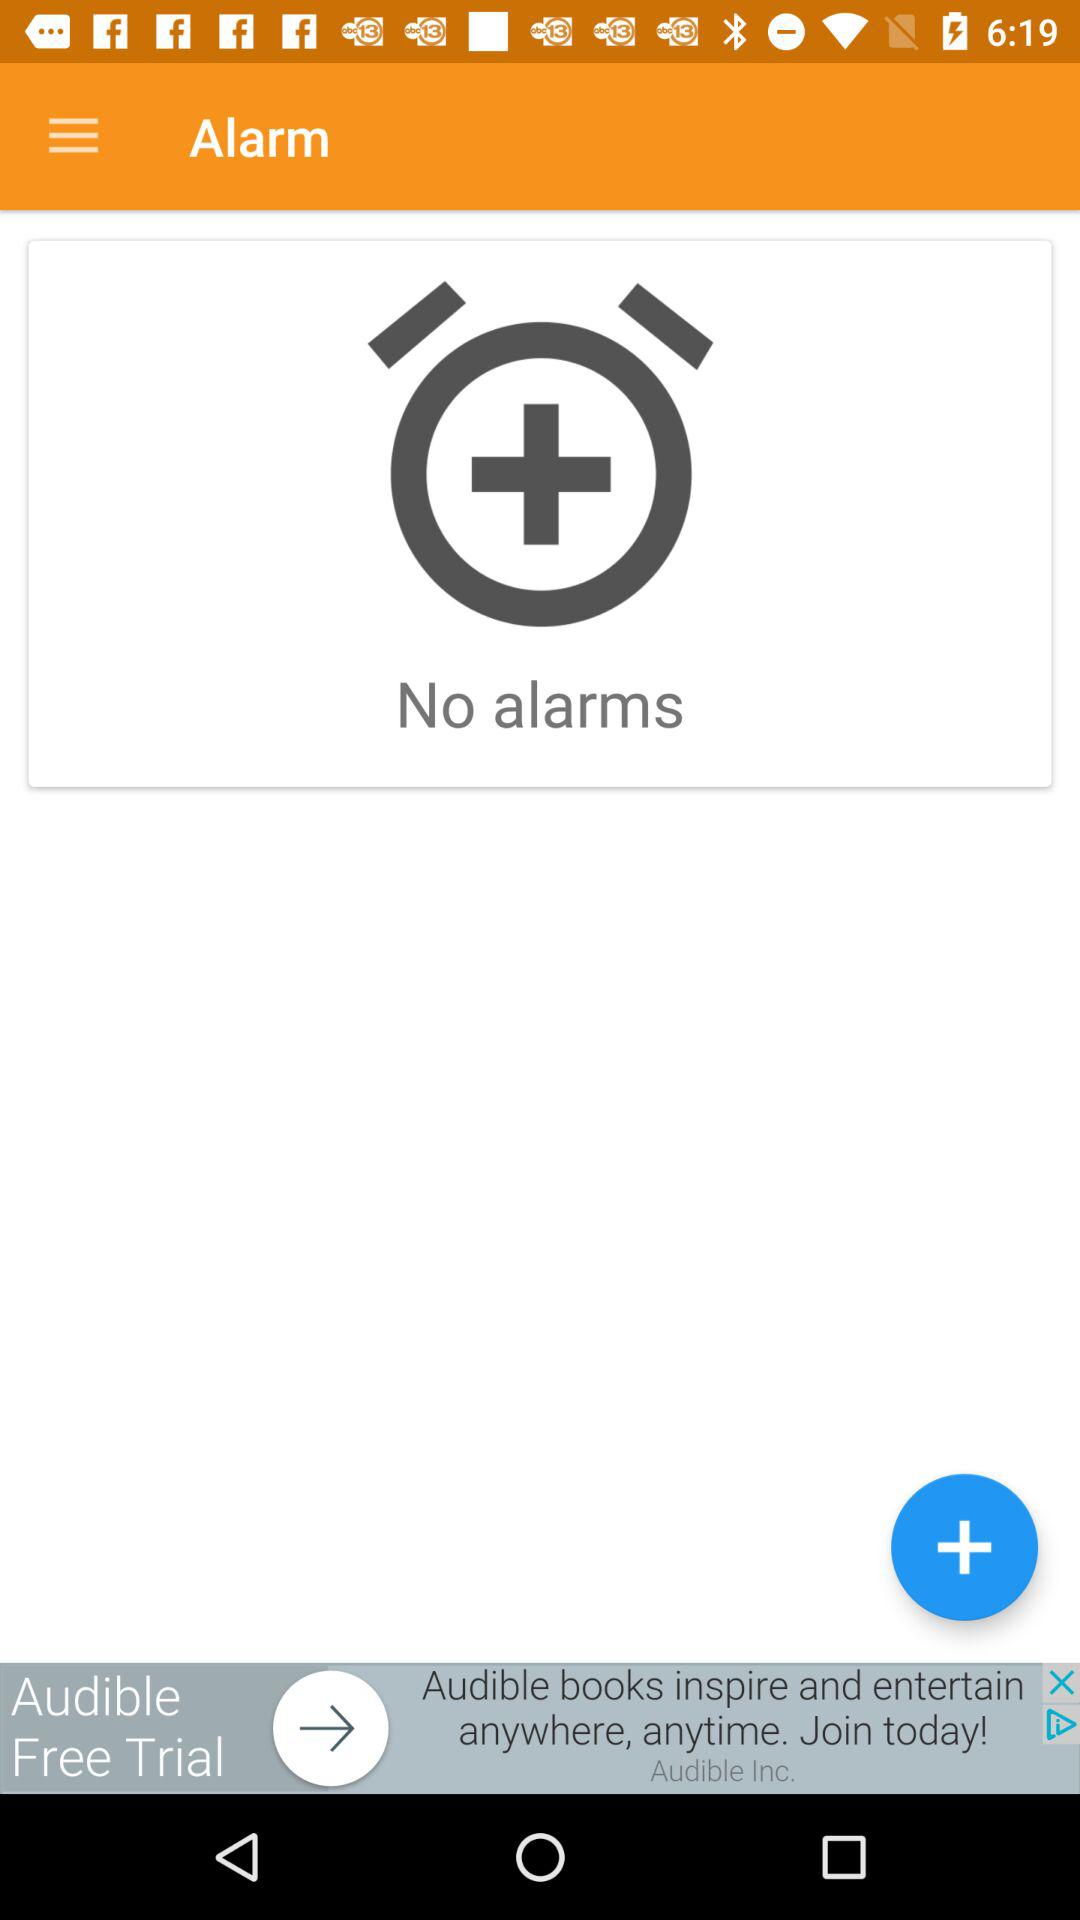What is the application name? The application name is "Alarm". 